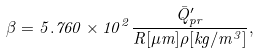<formula> <loc_0><loc_0><loc_500><loc_500>\beta = 5 . 7 6 0 \times 1 0 ^ { 2 } \frac { \bar { Q } ^ { \prime } _ { p r } } { R [ \mu m ] \rho [ k g / m ^ { 3 } ] } ,</formula> 